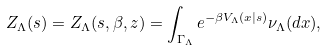Convert formula to latex. <formula><loc_0><loc_0><loc_500><loc_500>Z _ { \Lambda } ( s ) = Z _ { \Lambda } ( s , \beta , z ) = \int _ { \Gamma _ { \Lambda } } e ^ { - \beta V _ { \Lambda } ( x | s ) } \nu _ { \Lambda } ( d x ) ,</formula> 